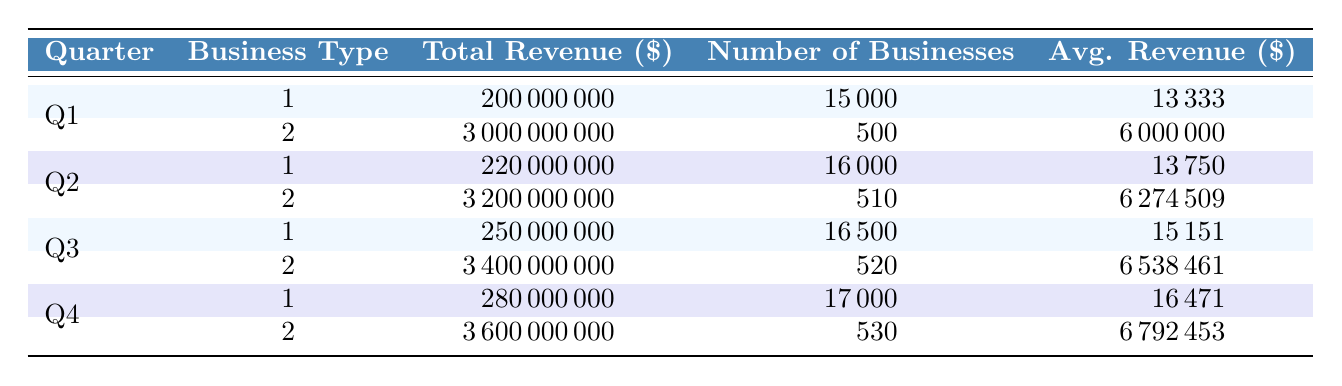What was the total revenue for small businesses in Q1? The table shows that in Q1, the total revenue for small businesses is listed as 200,000,000 dollars.
Answer: 200000000 What was the average revenue per large corporation in Q4? From the table, in Q4, the average revenue per large corporation is listed as 6,792,453 dollars.
Answer: 6792453 Which quarter had the highest total revenue for small businesses? By reviewing the quarterly revenue data, Q4 has the highest total revenue for small businesses at 280,000,000 dollars compared to other quarters.
Answer: Q4 What is the difference in average revenue per business between small businesses and large corporations in Q2? The average revenue per small business in Q2 is 13,750 dollars, while for large corporations it is 6,274,509 dollars. The difference is 6,274,509 - 13,750 = 6,260,759 dollars.
Answer: 6260759 True or False: In Q3, the total revenue for large corporations surpassed 3 billion dollars. The table indicates that the total revenue for large corporations in Q3 is 3,400,000,000 dollars, which is indeed greater than 3 billion dollars.
Answer: True Which business type had more total revenue in Q1, and by how much? In Q1, small businesses had a total revenue of 200,000,000 dollars, while large corporations had 3,000,000,000 dollars. The difference is 3,000,000,000 - 200,000,000 = 2,800,000,000 dollars, meaning large corporations had more revenue by this amount.
Answer: Large corporations by 2800000000 What was the total revenue for small businesses across all quarters in 2022? The total revenue for small businesses across the four quarters is the sum of the revenue from each: 200,000,000 + 220,000,000 + 250,000,000 + 280,000,000 = 950,000,000 dollars.
Answer: 950000000 In which quarter did small businesses see the smallest average revenue per business? By comparing the average revenue per business values, Q1 had the smallest average revenue for small businesses at 13,333 dollars. All other quarters had higher averages.
Answer: Q1 What was the increase in the number of large corporations from Q1 to Q4? The number of large corporations in Q1 was 500, and in Q4 it was 530. The increase is calculated as 530 - 500 = 30 corporations.
Answer: 30 